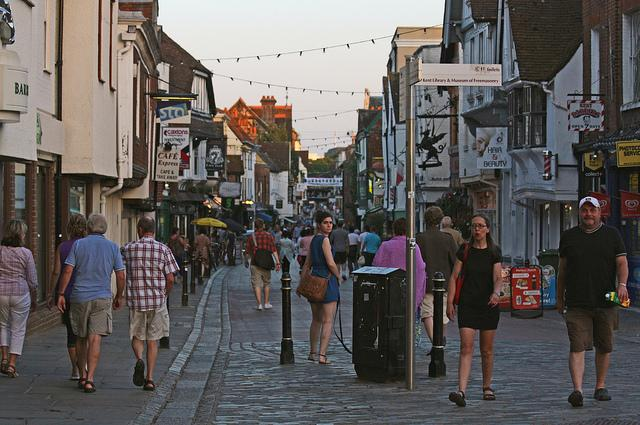What kind of area in town is this?

Choices:
A) shopping area
B) industrial
C) residential area
D) office buildings shopping area 